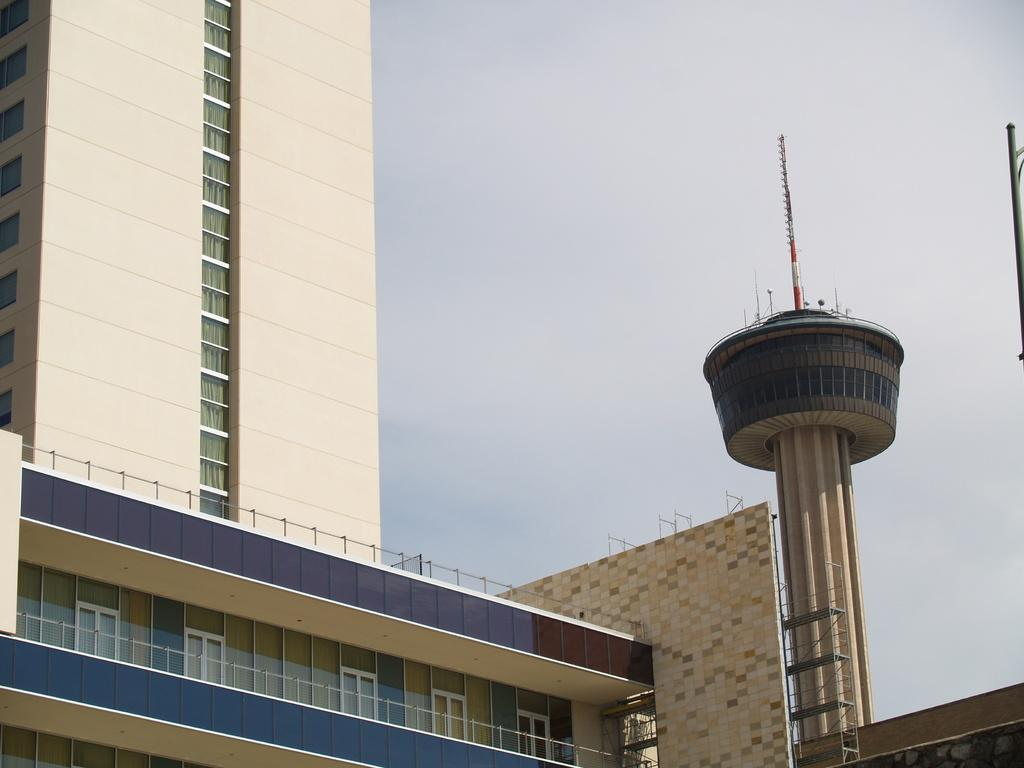What type of structure is present in the image? There is a building in the image. What colors are used on the building? The building has a cream and blue color. What feature can be seen on the right side of the building? There is a tower on the right side of the building. What can be seen in the background of the image? The sky is visible in the background of the image. Is there a library inside the building in the image? The image does not provide information about the interior of the building, so it cannot be determined if there is a library inside. 